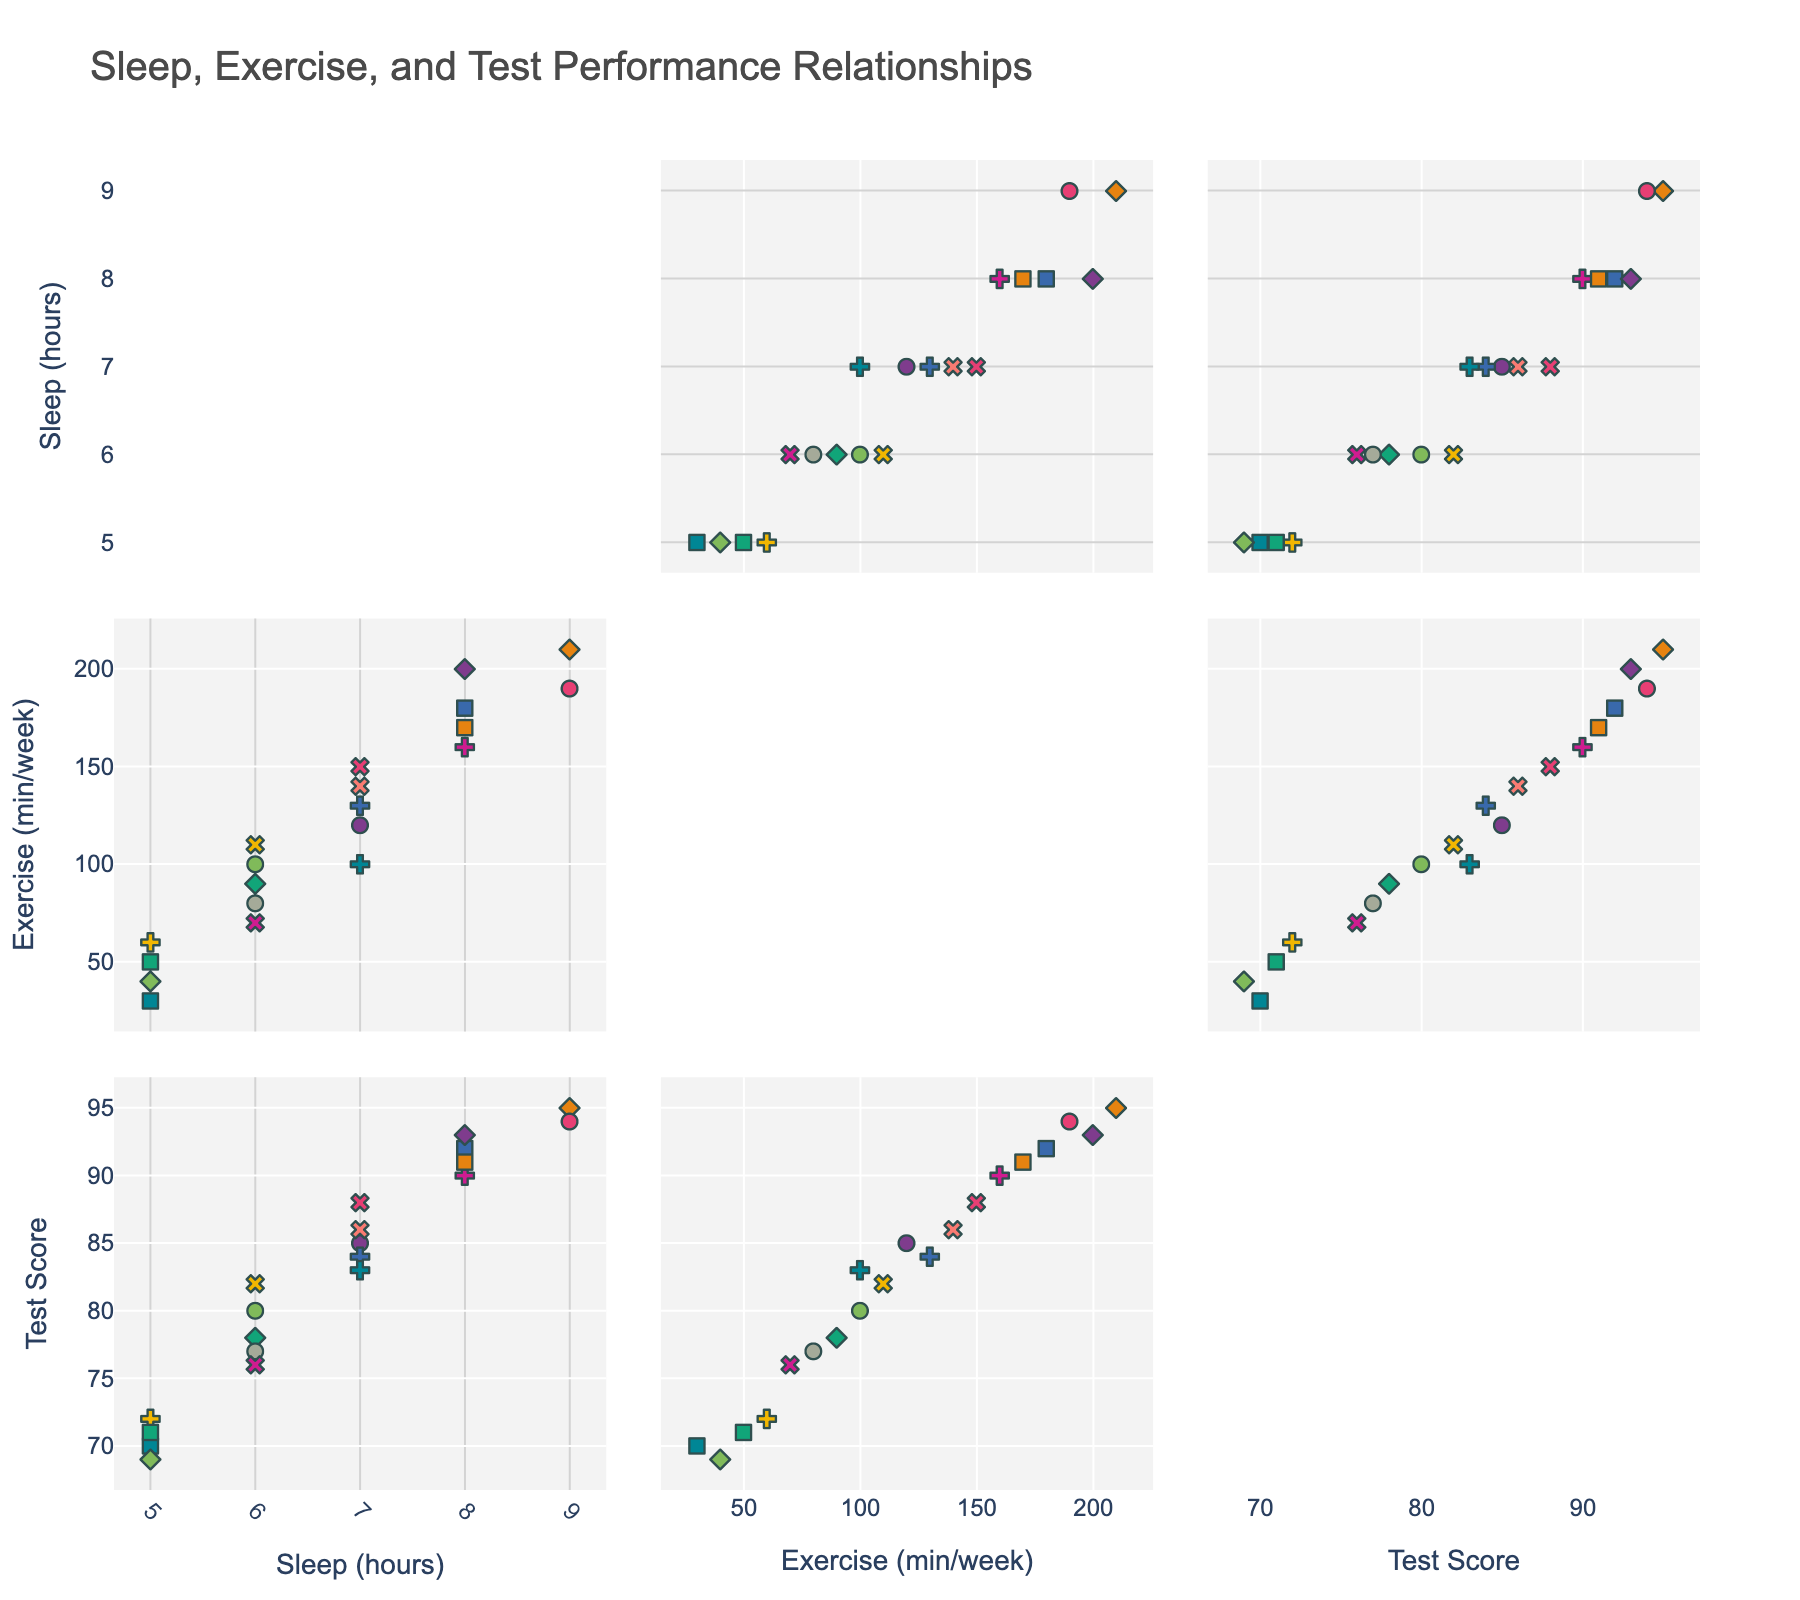What is the title of the figure? The title is displayed at the top of the figure and typically provides a summary of what the figure represents. In this case, it's centered and says "Distribution of Fair Play Violations by Sport".
Answer: Distribution of Fair Play Violations by Sport Which sport has the highest number of fair play violations? To find this, look at the sectors in the pie chart. The largest sector represents the sport with the highest number of violations, which is Boxing.
Answer: Boxing How many sports have more than 20 fair play violations? You need to identify the sectors with values over 20. Boxing, Wrestling, and Cycling all have more than 20 violations.
Answer: 3 What percentage of the total fair play violations does Wrestling account for? Find the sector for Wrestling. Its percentage can be read directly from the chart.
Answer: 15% Compare the number of fair play violations in Athletics to Swimming. Which is higher, and by how much? Look at the sectors for Athletics and Swimming. Athletics has 15 violations, Swimming has 8. The difference is 15 - 8.
Answer: Athletics, 7 Which two sports have the least fair play violations and how many do they have combined? Look for the smallest sectors in the pie chart, which are Tennis and Basketball, having 5 and 7 violations respectively. Add them together.
Answer: Tennis and Basketball, 12 What sport accounts for approximately 20% of the fair play violations? Find the sector that matches approximately 20% in size. Weightlifting is around this percentage.
Answer: Weightlifting If you combine the fair play violations in Gymnastics and Football, what percentage of the total do they represent? Sum the violations of both sports (Gymnastics: 12, Football: 10) and then calculate their combined percentage.
Answer: 22 What is the combined total of fair play violations for all sports listed? Sum all the values given: 15 (Athletics) + 8 (Swimming) + 12 (Gymnastics) + 22 (Cycling) + 25 (Wrestling) + 30 (Boxing) + 18 (Weightlifting) + 10 (Football) + 7 (Basketball) + 5 (Tennis).
Answer: 152 Which sport has exactly half the number of fair play violations as Boxing? First note that Boxing has 30 violations. We need a sport with 15 violations, which is Athletics.
Answer: Athletics 